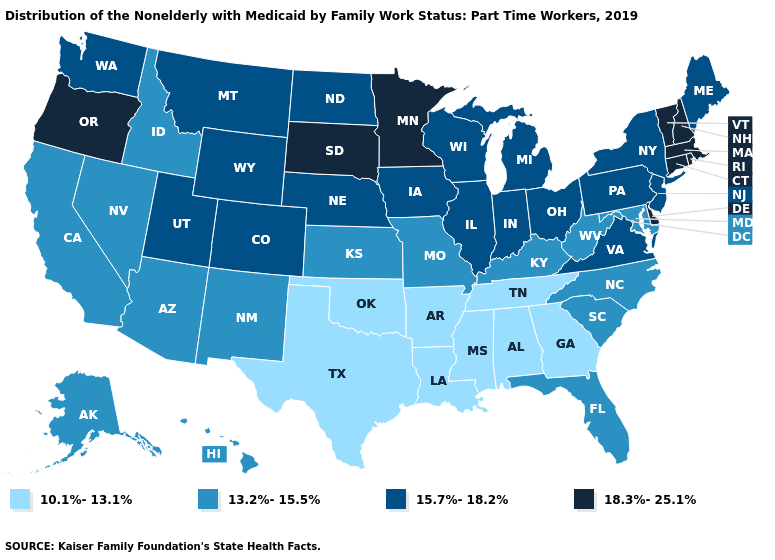Name the states that have a value in the range 10.1%-13.1%?
Write a very short answer. Alabama, Arkansas, Georgia, Louisiana, Mississippi, Oklahoma, Tennessee, Texas. Does the map have missing data?
Give a very brief answer. No. Which states hav the highest value in the West?
Quick response, please. Oregon. Does South Carolina have the same value as Alabama?
Give a very brief answer. No. Which states hav the highest value in the MidWest?
Be succinct. Minnesota, South Dakota. How many symbols are there in the legend?
Be succinct. 4. What is the lowest value in the South?
Short answer required. 10.1%-13.1%. Name the states that have a value in the range 10.1%-13.1%?
Keep it brief. Alabama, Arkansas, Georgia, Louisiana, Mississippi, Oklahoma, Tennessee, Texas. Name the states that have a value in the range 13.2%-15.5%?
Short answer required. Alaska, Arizona, California, Florida, Hawaii, Idaho, Kansas, Kentucky, Maryland, Missouri, Nevada, New Mexico, North Carolina, South Carolina, West Virginia. Name the states that have a value in the range 18.3%-25.1%?
Short answer required. Connecticut, Delaware, Massachusetts, Minnesota, New Hampshire, Oregon, Rhode Island, South Dakota, Vermont. Name the states that have a value in the range 15.7%-18.2%?
Quick response, please. Colorado, Illinois, Indiana, Iowa, Maine, Michigan, Montana, Nebraska, New Jersey, New York, North Dakota, Ohio, Pennsylvania, Utah, Virginia, Washington, Wisconsin, Wyoming. Among the states that border Louisiana , which have the highest value?
Keep it brief. Arkansas, Mississippi, Texas. Among the states that border Texas , which have the lowest value?
Write a very short answer. Arkansas, Louisiana, Oklahoma. What is the value of Pennsylvania?
Be succinct. 15.7%-18.2%. Does Rhode Island have a higher value than Massachusetts?
Be succinct. No. 